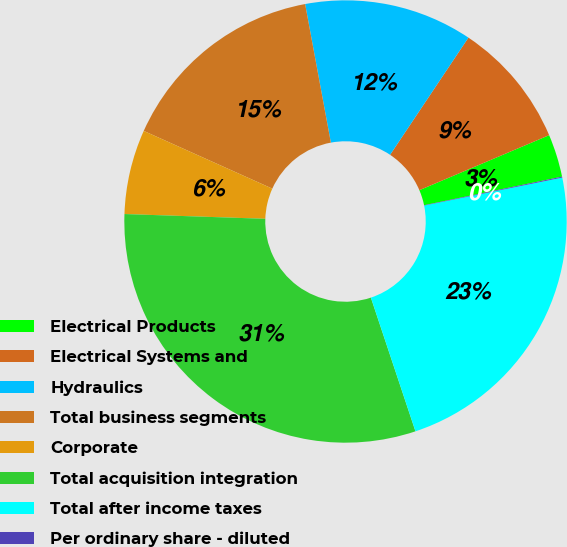Convert chart to OTSL. <chart><loc_0><loc_0><loc_500><loc_500><pie_chart><fcel>Electrical Products<fcel>Electrical Systems and<fcel>Hydraulics<fcel>Total business segments<fcel>Corporate<fcel>Total acquisition integration<fcel>Total after income taxes<fcel>Per ordinary share - diluted<nl><fcel>3.13%<fcel>9.24%<fcel>12.3%<fcel>15.36%<fcel>6.18%<fcel>30.66%<fcel>23.06%<fcel>0.07%<nl></chart> 